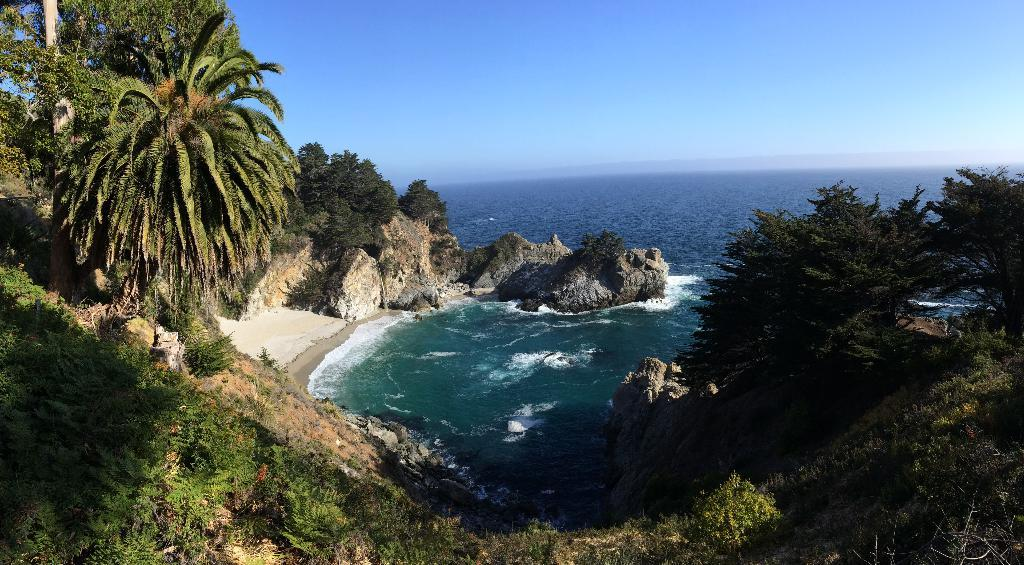What is the main feature in the center of the image? There is an ocean in the center of the image. What type of vegetation can be seen on the right side of the image? There are trees on the right side of the image. What type of vegetation can be seen on the left side of the image? There are trees on the left side of the image. What type of geological formations are present on the right side of the image? There are rocks on the right side of the image. What type of geological formations are present on the left side of the image? There are rocks on the left side of the image. What is visible at the top of the image? The sky is visible at the top of the image. What is the title of the lumber yard in the image? There is no lumber yard or title present in the image. 